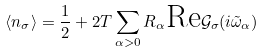<formula> <loc_0><loc_0><loc_500><loc_500>\langle n _ { \sigma } \rangle = \frac { 1 } { 2 } + 2 T \sum _ { \alpha > 0 } R _ { \alpha } \text {Re} \mathcal { G } _ { \sigma } ( i \tilde { \omega } _ { \alpha } )</formula> 